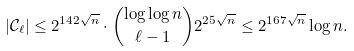<formula> <loc_0><loc_0><loc_500><loc_500>| \mathcal { C } _ { \ell } | & \leq 2 ^ { 1 4 2 \sqrt { n } } \cdot \binom { \log \log n } { \ell - 1 } 2 ^ { 2 5 \sqrt { n } } \leq 2 ^ { 1 6 7 \sqrt { n } } \log n .</formula> 